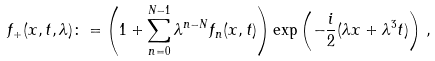<formula> <loc_0><loc_0><loc_500><loc_500>f _ { + } ( x , t , \lambda ) \colon = \left ( 1 + \sum _ { n = 0 } ^ { N - 1 } \lambda ^ { n - N } f _ { n } ( x , t ) \right ) \exp \left ( - \frac { i } { 2 } ( \lambda x + \lambda ^ { 3 } t ) \right ) \, ,</formula> 